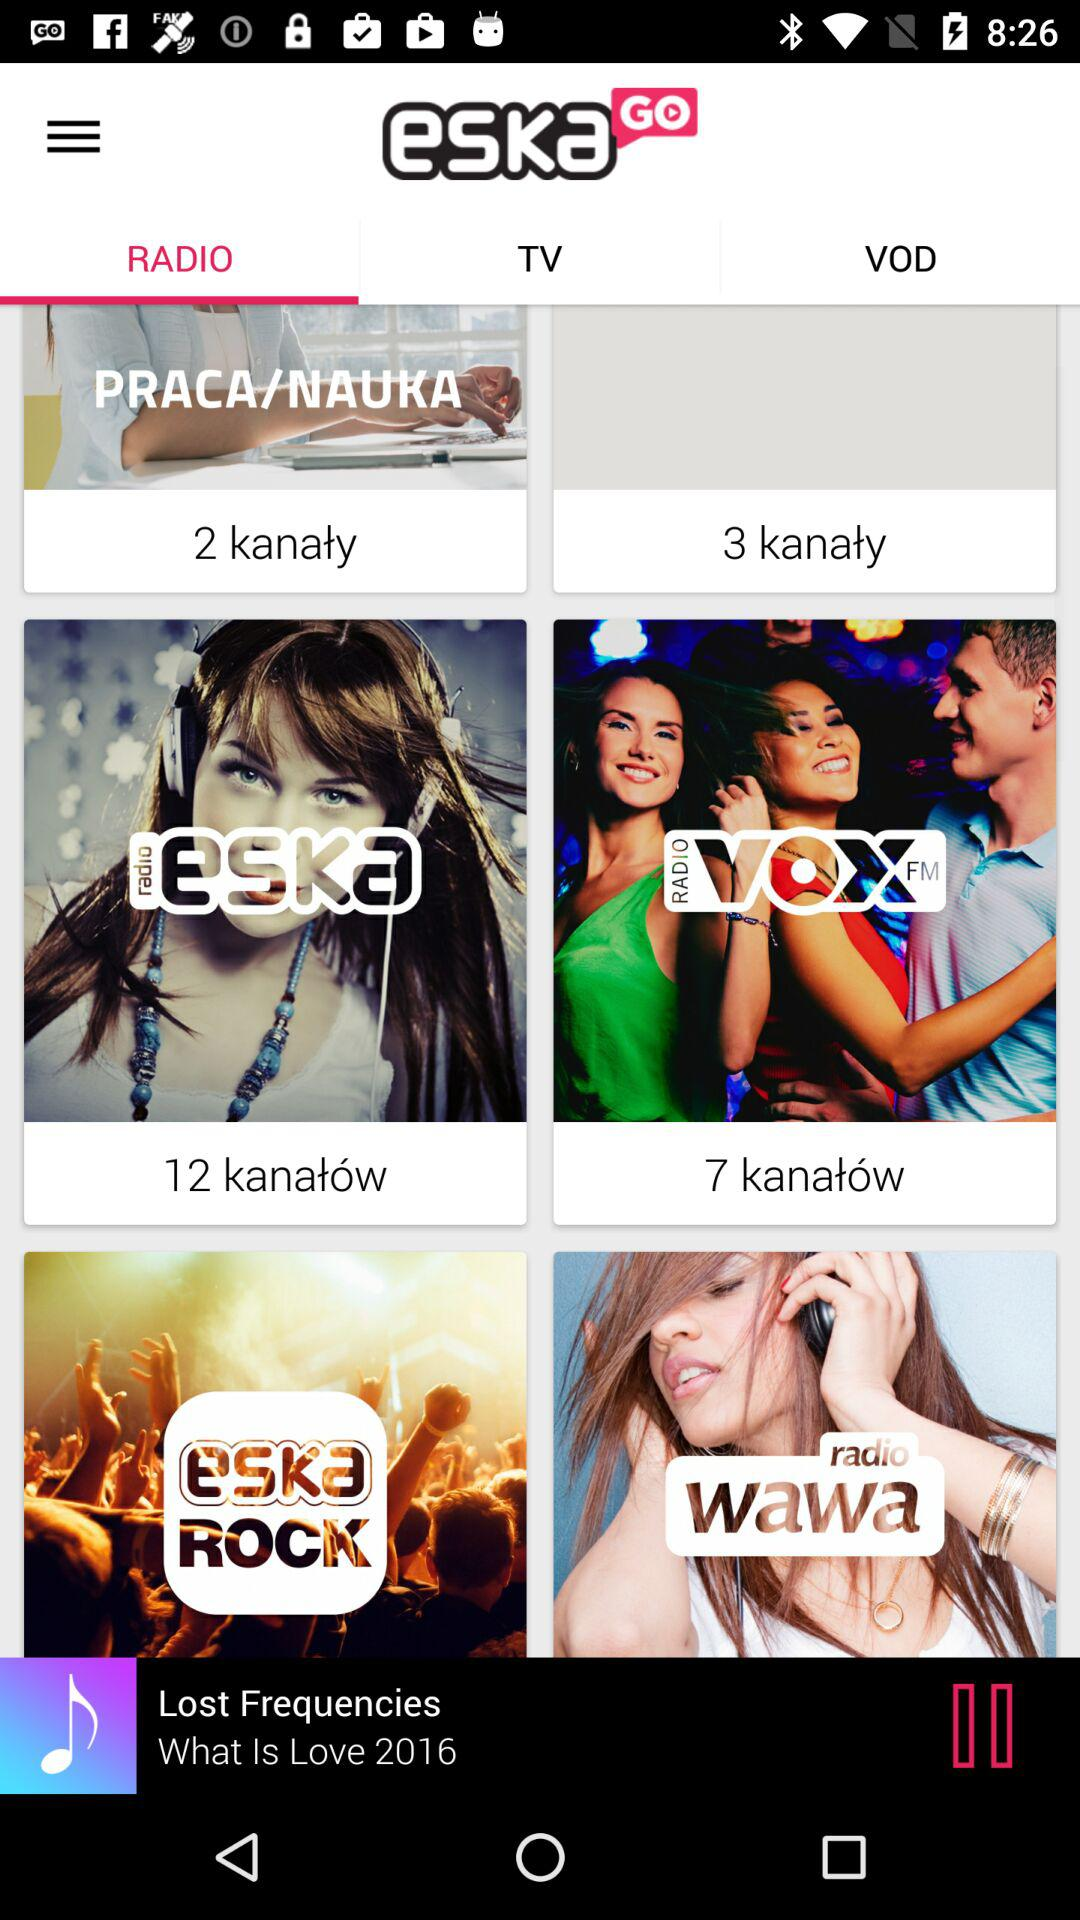How many more channels are there in the 'ESKA' category than in the 'PRACA/NAUKA' category?
Answer the question using a single word or phrase. 10 